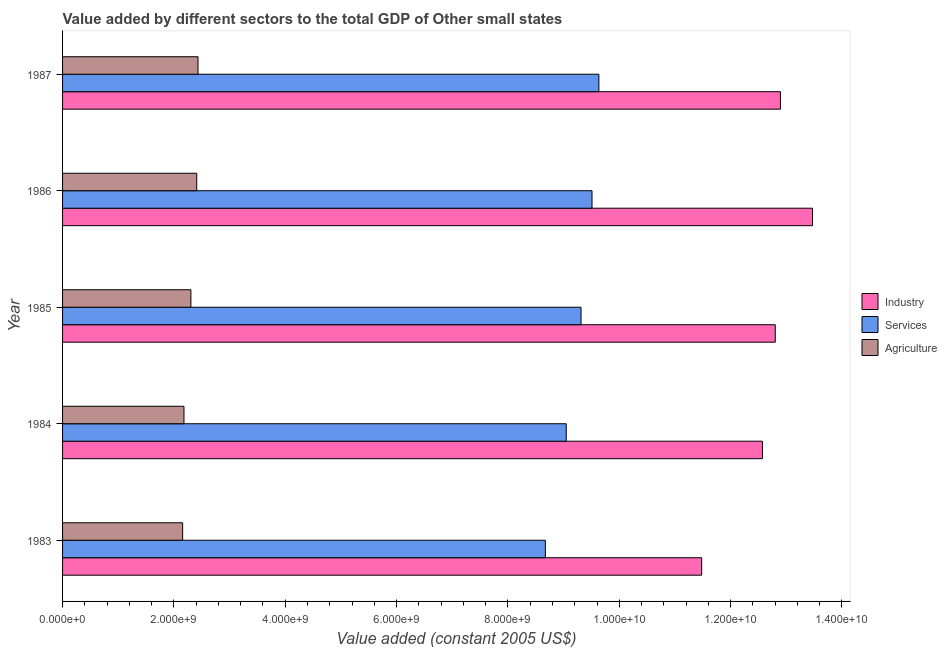How many groups of bars are there?
Give a very brief answer. 5. Are the number of bars per tick equal to the number of legend labels?
Give a very brief answer. Yes. Are the number of bars on each tick of the Y-axis equal?
Keep it short and to the point. Yes. In how many cases, is the number of bars for a given year not equal to the number of legend labels?
Your response must be concise. 0. What is the value added by agricultural sector in 1984?
Keep it short and to the point. 2.18e+09. Across all years, what is the maximum value added by agricultural sector?
Your response must be concise. 2.43e+09. Across all years, what is the minimum value added by industrial sector?
Make the answer very short. 1.15e+1. What is the total value added by industrial sector in the graph?
Your answer should be compact. 6.32e+1. What is the difference between the value added by services in 1983 and that in 1984?
Keep it short and to the point. -3.75e+08. What is the difference between the value added by industrial sector in 1985 and the value added by agricultural sector in 1983?
Provide a succinct answer. 1.06e+1. What is the average value added by services per year?
Ensure brevity in your answer.  9.23e+09. In the year 1983, what is the difference between the value added by services and value added by industrial sector?
Provide a short and direct response. -2.81e+09. In how many years, is the value added by services greater than 1600000000 US$?
Offer a very short reply. 5. What is the ratio of the value added by services in 1983 to that in 1986?
Make the answer very short. 0.91. Is the value added by industrial sector in 1986 less than that in 1987?
Your answer should be compact. No. Is the difference between the value added by industrial sector in 1985 and 1986 greater than the difference between the value added by services in 1985 and 1986?
Provide a short and direct response. No. What is the difference between the highest and the second highest value added by industrial sector?
Offer a terse response. 5.76e+08. What is the difference between the highest and the lowest value added by agricultural sector?
Provide a short and direct response. 2.76e+08. In how many years, is the value added by agricultural sector greater than the average value added by agricultural sector taken over all years?
Provide a short and direct response. 3. What does the 2nd bar from the top in 1987 represents?
Your answer should be compact. Services. What does the 1st bar from the bottom in 1987 represents?
Give a very brief answer. Industry. How many bars are there?
Offer a very short reply. 15. How many years are there in the graph?
Your answer should be compact. 5. Are the values on the major ticks of X-axis written in scientific E-notation?
Your answer should be compact. Yes. Does the graph contain any zero values?
Your answer should be compact. No. Does the graph contain grids?
Your answer should be compact. No. Where does the legend appear in the graph?
Provide a short and direct response. Center right. How many legend labels are there?
Make the answer very short. 3. How are the legend labels stacked?
Offer a terse response. Vertical. What is the title of the graph?
Ensure brevity in your answer.  Value added by different sectors to the total GDP of Other small states. What is the label or title of the X-axis?
Your response must be concise. Value added (constant 2005 US$). What is the label or title of the Y-axis?
Make the answer very short. Year. What is the Value added (constant 2005 US$) in Industry in 1983?
Keep it short and to the point. 1.15e+1. What is the Value added (constant 2005 US$) of Services in 1983?
Offer a terse response. 8.67e+09. What is the Value added (constant 2005 US$) of Agriculture in 1983?
Offer a very short reply. 2.16e+09. What is the Value added (constant 2005 US$) in Industry in 1984?
Your response must be concise. 1.26e+1. What is the Value added (constant 2005 US$) in Services in 1984?
Provide a succinct answer. 9.05e+09. What is the Value added (constant 2005 US$) in Agriculture in 1984?
Ensure brevity in your answer.  2.18e+09. What is the Value added (constant 2005 US$) in Industry in 1985?
Give a very brief answer. 1.28e+1. What is the Value added (constant 2005 US$) in Services in 1985?
Offer a very short reply. 9.31e+09. What is the Value added (constant 2005 US$) in Agriculture in 1985?
Offer a terse response. 2.30e+09. What is the Value added (constant 2005 US$) in Industry in 1986?
Make the answer very short. 1.35e+1. What is the Value added (constant 2005 US$) in Services in 1986?
Your answer should be compact. 9.51e+09. What is the Value added (constant 2005 US$) of Agriculture in 1986?
Your answer should be very brief. 2.41e+09. What is the Value added (constant 2005 US$) of Industry in 1987?
Provide a succinct answer. 1.29e+1. What is the Value added (constant 2005 US$) in Services in 1987?
Your response must be concise. 9.63e+09. What is the Value added (constant 2005 US$) in Agriculture in 1987?
Ensure brevity in your answer.  2.43e+09. Across all years, what is the maximum Value added (constant 2005 US$) of Industry?
Keep it short and to the point. 1.35e+1. Across all years, what is the maximum Value added (constant 2005 US$) in Services?
Provide a succinct answer. 9.63e+09. Across all years, what is the maximum Value added (constant 2005 US$) of Agriculture?
Offer a terse response. 2.43e+09. Across all years, what is the minimum Value added (constant 2005 US$) in Industry?
Offer a very short reply. 1.15e+1. Across all years, what is the minimum Value added (constant 2005 US$) in Services?
Provide a succinct answer. 8.67e+09. Across all years, what is the minimum Value added (constant 2005 US$) in Agriculture?
Your response must be concise. 2.16e+09. What is the total Value added (constant 2005 US$) in Industry in the graph?
Your answer should be very brief. 6.32e+1. What is the total Value added (constant 2005 US$) of Services in the graph?
Offer a very short reply. 4.62e+1. What is the total Value added (constant 2005 US$) in Agriculture in the graph?
Make the answer very short. 1.15e+1. What is the difference between the Value added (constant 2005 US$) of Industry in 1983 and that in 1984?
Provide a succinct answer. -1.09e+09. What is the difference between the Value added (constant 2005 US$) in Services in 1983 and that in 1984?
Provide a short and direct response. -3.75e+08. What is the difference between the Value added (constant 2005 US$) of Agriculture in 1983 and that in 1984?
Give a very brief answer. -2.37e+07. What is the difference between the Value added (constant 2005 US$) of Industry in 1983 and that in 1985?
Provide a short and direct response. -1.32e+09. What is the difference between the Value added (constant 2005 US$) of Services in 1983 and that in 1985?
Your answer should be very brief. -6.41e+08. What is the difference between the Value added (constant 2005 US$) in Agriculture in 1983 and that in 1985?
Provide a short and direct response. -1.48e+08. What is the difference between the Value added (constant 2005 US$) of Industry in 1983 and that in 1986?
Offer a very short reply. -1.99e+09. What is the difference between the Value added (constant 2005 US$) in Services in 1983 and that in 1986?
Your answer should be compact. -8.38e+08. What is the difference between the Value added (constant 2005 US$) of Agriculture in 1983 and that in 1986?
Provide a short and direct response. -2.53e+08. What is the difference between the Value added (constant 2005 US$) in Industry in 1983 and that in 1987?
Your answer should be very brief. -1.42e+09. What is the difference between the Value added (constant 2005 US$) of Services in 1983 and that in 1987?
Ensure brevity in your answer.  -9.61e+08. What is the difference between the Value added (constant 2005 US$) of Agriculture in 1983 and that in 1987?
Ensure brevity in your answer.  -2.76e+08. What is the difference between the Value added (constant 2005 US$) of Industry in 1984 and that in 1985?
Make the answer very short. -2.31e+08. What is the difference between the Value added (constant 2005 US$) of Services in 1984 and that in 1985?
Make the answer very short. -2.66e+08. What is the difference between the Value added (constant 2005 US$) of Agriculture in 1984 and that in 1985?
Your response must be concise. -1.24e+08. What is the difference between the Value added (constant 2005 US$) in Industry in 1984 and that in 1986?
Keep it short and to the point. -8.99e+08. What is the difference between the Value added (constant 2005 US$) of Services in 1984 and that in 1986?
Ensure brevity in your answer.  -4.63e+08. What is the difference between the Value added (constant 2005 US$) in Agriculture in 1984 and that in 1986?
Provide a succinct answer. -2.29e+08. What is the difference between the Value added (constant 2005 US$) in Industry in 1984 and that in 1987?
Keep it short and to the point. -3.24e+08. What is the difference between the Value added (constant 2005 US$) in Services in 1984 and that in 1987?
Offer a terse response. -5.86e+08. What is the difference between the Value added (constant 2005 US$) in Agriculture in 1984 and that in 1987?
Your response must be concise. -2.52e+08. What is the difference between the Value added (constant 2005 US$) in Industry in 1985 and that in 1986?
Give a very brief answer. -6.69e+08. What is the difference between the Value added (constant 2005 US$) in Services in 1985 and that in 1986?
Your answer should be very brief. -1.97e+08. What is the difference between the Value added (constant 2005 US$) in Agriculture in 1985 and that in 1986?
Ensure brevity in your answer.  -1.05e+08. What is the difference between the Value added (constant 2005 US$) of Industry in 1985 and that in 1987?
Your answer should be compact. -9.30e+07. What is the difference between the Value added (constant 2005 US$) in Services in 1985 and that in 1987?
Provide a short and direct response. -3.20e+08. What is the difference between the Value added (constant 2005 US$) of Agriculture in 1985 and that in 1987?
Make the answer very short. -1.28e+08. What is the difference between the Value added (constant 2005 US$) in Industry in 1986 and that in 1987?
Offer a terse response. 5.76e+08. What is the difference between the Value added (constant 2005 US$) in Services in 1986 and that in 1987?
Keep it short and to the point. -1.23e+08. What is the difference between the Value added (constant 2005 US$) of Agriculture in 1986 and that in 1987?
Provide a succinct answer. -2.30e+07. What is the difference between the Value added (constant 2005 US$) in Industry in 1983 and the Value added (constant 2005 US$) in Services in 1984?
Provide a succinct answer. 2.43e+09. What is the difference between the Value added (constant 2005 US$) in Industry in 1983 and the Value added (constant 2005 US$) in Agriculture in 1984?
Give a very brief answer. 9.30e+09. What is the difference between the Value added (constant 2005 US$) of Services in 1983 and the Value added (constant 2005 US$) of Agriculture in 1984?
Make the answer very short. 6.49e+09. What is the difference between the Value added (constant 2005 US$) in Industry in 1983 and the Value added (constant 2005 US$) in Services in 1985?
Ensure brevity in your answer.  2.17e+09. What is the difference between the Value added (constant 2005 US$) in Industry in 1983 and the Value added (constant 2005 US$) in Agriculture in 1985?
Provide a succinct answer. 9.17e+09. What is the difference between the Value added (constant 2005 US$) of Services in 1983 and the Value added (constant 2005 US$) of Agriculture in 1985?
Make the answer very short. 6.37e+09. What is the difference between the Value added (constant 2005 US$) of Industry in 1983 and the Value added (constant 2005 US$) of Services in 1986?
Your answer should be very brief. 1.97e+09. What is the difference between the Value added (constant 2005 US$) of Industry in 1983 and the Value added (constant 2005 US$) of Agriculture in 1986?
Provide a short and direct response. 9.07e+09. What is the difference between the Value added (constant 2005 US$) in Services in 1983 and the Value added (constant 2005 US$) in Agriculture in 1986?
Offer a very short reply. 6.26e+09. What is the difference between the Value added (constant 2005 US$) of Industry in 1983 and the Value added (constant 2005 US$) of Services in 1987?
Provide a short and direct response. 1.85e+09. What is the difference between the Value added (constant 2005 US$) of Industry in 1983 and the Value added (constant 2005 US$) of Agriculture in 1987?
Ensure brevity in your answer.  9.05e+09. What is the difference between the Value added (constant 2005 US$) of Services in 1983 and the Value added (constant 2005 US$) of Agriculture in 1987?
Ensure brevity in your answer.  6.24e+09. What is the difference between the Value added (constant 2005 US$) in Industry in 1984 and the Value added (constant 2005 US$) in Services in 1985?
Offer a terse response. 3.26e+09. What is the difference between the Value added (constant 2005 US$) of Industry in 1984 and the Value added (constant 2005 US$) of Agriculture in 1985?
Ensure brevity in your answer.  1.03e+1. What is the difference between the Value added (constant 2005 US$) in Services in 1984 and the Value added (constant 2005 US$) in Agriculture in 1985?
Keep it short and to the point. 6.74e+09. What is the difference between the Value added (constant 2005 US$) of Industry in 1984 and the Value added (constant 2005 US$) of Services in 1986?
Provide a succinct answer. 3.06e+09. What is the difference between the Value added (constant 2005 US$) in Industry in 1984 and the Value added (constant 2005 US$) in Agriculture in 1986?
Offer a very short reply. 1.02e+1. What is the difference between the Value added (constant 2005 US$) of Services in 1984 and the Value added (constant 2005 US$) of Agriculture in 1986?
Provide a short and direct response. 6.64e+09. What is the difference between the Value added (constant 2005 US$) in Industry in 1984 and the Value added (constant 2005 US$) in Services in 1987?
Your answer should be compact. 2.94e+09. What is the difference between the Value added (constant 2005 US$) in Industry in 1984 and the Value added (constant 2005 US$) in Agriculture in 1987?
Your answer should be compact. 1.01e+1. What is the difference between the Value added (constant 2005 US$) in Services in 1984 and the Value added (constant 2005 US$) in Agriculture in 1987?
Your answer should be compact. 6.61e+09. What is the difference between the Value added (constant 2005 US$) of Industry in 1985 and the Value added (constant 2005 US$) of Services in 1986?
Keep it short and to the point. 3.29e+09. What is the difference between the Value added (constant 2005 US$) of Industry in 1985 and the Value added (constant 2005 US$) of Agriculture in 1986?
Ensure brevity in your answer.  1.04e+1. What is the difference between the Value added (constant 2005 US$) in Services in 1985 and the Value added (constant 2005 US$) in Agriculture in 1986?
Keep it short and to the point. 6.90e+09. What is the difference between the Value added (constant 2005 US$) in Industry in 1985 and the Value added (constant 2005 US$) in Services in 1987?
Keep it short and to the point. 3.17e+09. What is the difference between the Value added (constant 2005 US$) in Industry in 1985 and the Value added (constant 2005 US$) in Agriculture in 1987?
Give a very brief answer. 1.04e+1. What is the difference between the Value added (constant 2005 US$) of Services in 1985 and the Value added (constant 2005 US$) of Agriculture in 1987?
Ensure brevity in your answer.  6.88e+09. What is the difference between the Value added (constant 2005 US$) of Industry in 1986 and the Value added (constant 2005 US$) of Services in 1987?
Give a very brief answer. 3.84e+09. What is the difference between the Value added (constant 2005 US$) of Industry in 1986 and the Value added (constant 2005 US$) of Agriculture in 1987?
Offer a very short reply. 1.10e+1. What is the difference between the Value added (constant 2005 US$) in Services in 1986 and the Value added (constant 2005 US$) in Agriculture in 1987?
Offer a very short reply. 7.08e+09. What is the average Value added (constant 2005 US$) in Industry per year?
Your response must be concise. 1.26e+1. What is the average Value added (constant 2005 US$) of Services per year?
Ensure brevity in your answer.  9.23e+09. What is the average Value added (constant 2005 US$) in Agriculture per year?
Make the answer very short. 2.30e+09. In the year 1983, what is the difference between the Value added (constant 2005 US$) in Industry and Value added (constant 2005 US$) in Services?
Make the answer very short. 2.81e+09. In the year 1983, what is the difference between the Value added (constant 2005 US$) of Industry and Value added (constant 2005 US$) of Agriculture?
Offer a terse response. 9.32e+09. In the year 1983, what is the difference between the Value added (constant 2005 US$) in Services and Value added (constant 2005 US$) in Agriculture?
Give a very brief answer. 6.51e+09. In the year 1984, what is the difference between the Value added (constant 2005 US$) in Industry and Value added (constant 2005 US$) in Services?
Give a very brief answer. 3.52e+09. In the year 1984, what is the difference between the Value added (constant 2005 US$) in Industry and Value added (constant 2005 US$) in Agriculture?
Offer a terse response. 1.04e+1. In the year 1984, what is the difference between the Value added (constant 2005 US$) of Services and Value added (constant 2005 US$) of Agriculture?
Keep it short and to the point. 6.87e+09. In the year 1985, what is the difference between the Value added (constant 2005 US$) of Industry and Value added (constant 2005 US$) of Services?
Ensure brevity in your answer.  3.49e+09. In the year 1985, what is the difference between the Value added (constant 2005 US$) of Industry and Value added (constant 2005 US$) of Agriculture?
Provide a short and direct response. 1.05e+1. In the year 1985, what is the difference between the Value added (constant 2005 US$) of Services and Value added (constant 2005 US$) of Agriculture?
Make the answer very short. 7.01e+09. In the year 1986, what is the difference between the Value added (constant 2005 US$) of Industry and Value added (constant 2005 US$) of Services?
Ensure brevity in your answer.  3.96e+09. In the year 1986, what is the difference between the Value added (constant 2005 US$) of Industry and Value added (constant 2005 US$) of Agriculture?
Give a very brief answer. 1.11e+1. In the year 1986, what is the difference between the Value added (constant 2005 US$) of Services and Value added (constant 2005 US$) of Agriculture?
Offer a very short reply. 7.10e+09. In the year 1987, what is the difference between the Value added (constant 2005 US$) of Industry and Value added (constant 2005 US$) of Services?
Provide a short and direct response. 3.26e+09. In the year 1987, what is the difference between the Value added (constant 2005 US$) in Industry and Value added (constant 2005 US$) in Agriculture?
Offer a very short reply. 1.05e+1. In the year 1987, what is the difference between the Value added (constant 2005 US$) in Services and Value added (constant 2005 US$) in Agriculture?
Keep it short and to the point. 7.20e+09. What is the ratio of the Value added (constant 2005 US$) in Industry in 1983 to that in 1984?
Provide a short and direct response. 0.91. What is the ratio of the Value added (constant 2005 US$) of Services in 1983 to that in 1984?
Offer a terse response. 0.96. What is the ratio of the Value added (constant 2005 US$) of Agriculture in 1983 to that in 1984?
Give a very brief answer. 0.99. What is the ratio of the Value added (constant 2005 US$) of Industry in 1983 to that in 1985?
Offer a very short reply. 0.9. What is the ratio of the Value added (constant 2005 US$) in Services in 1983 to that in 1985?
Your answer should be compact. 0.93. What is the ratio of the Value added (constant 2005 US$) in Agriculture in 1983 to that in 1985?
Make the answer very short. 0.94. What is the ratio of the Value added (constant 2005 US$) in Industry in 1983 to that in 1986?
Your answer should be very brief. 0.85. What is the ratio of the Value added (constant 2005 US$) in Services in 1983 to that in 1986?
Ensure brevity in your answer.  0.91. What is the ratio of the Value added (constant 2005 US$) of Agriculture in 1983 to that in 1986?
Provide a succinct answer. 0.9. What is the ratio of the Value added (constant 2005 US$) of Industry in 1983 to that in 1987?
Make the answer very short. 0.89. What is the ratio of the Value added (constant 2005 US$) of Services in 1983 to that in 1987?
Offer a very short reply. 0.9. What is the ratio of the Value added (constant 2005 US$) of Agriculture in 1983 to that in 1987?
Offer a terse response. 0.89. What is the ratio of the Value added (constant 2005 US$) of Services in 1984 to that in 1985?
Ensure brevity in your answer.  0.97. What is the ratio of the Value added (constant 2005 US$) of Agriculture in 1984 to that in 1985?
Your response must be concise. 0.95. What is the ratio of the Value added (constant 2005 US$) of Industry in 1984 to that in 1986?
Make the answer very short. 0.93. What is the ratio of the Value added (constant 2005 US$) of Services in 1984 to that in 1986?
Provide a short and direct response. 0.95. What is the ratio of the Value added (constant 2005 US$) of Agriculture in 1984 to that in 1986?
Provide a short and direct response. 0.9. What is the ratio of the Value added (constant 2005 US$) in Industry in 1984 to that in 1987?
Your answer should be very brief. 0.97. What is the ratio of the Value added (constant 2005 US$) of Services in 1984 to that in 1987?
Give a very brief answer. 0.94. What is the ratio of the Value added (constant 2005 US$) of Agriculture in 1984 to that in 1987?
Give a very brief answer. 0.9. What is the ratio of the Value added (constant 2005 US$) in Industry in 1985 to that in 1986?
Your answer should be very brief. 0.95. What is the ratio of the Value added (constant 2005 US$) in Services in 1985 to that in 1986?
Offer a very short reply. 0.98. What is the ratio of the Value added (constant 2005 US$) in Agriculture in 1985 to that in 1986?
Provide a short and direct response. 0.96. What is the ratio of the Value added (constant 2005 US$) of Industry in 1985 to that in 1987?
Offer a very short reply. 0.99. What is the ratio of the Value added (constant 2005 US$) in Services in 1985 to that in 1987?
Offer a very short reply. 0.97. What is the ratio of the Value added (constant 2005 US$) in Agriculture in 1985 to that in 1987?
Provide a succinct answer. 0.95. What is the ratio of the Value added (constant 2005 US$) in Industry in 1986 to that in 1987?
Provide a succinct answer. 1.04. What is the ratio of the Value added (constant 2005 US$) of Services in 1986 to that in 1987?
Your answer should be compact. 0.99. What is the ratio of the Value added (constant 2005 US$) in Agriculture in 1986 to that in 1987?
Offer a very short reply. 0.99. What is the difference between the highest and the second highest Value added (constant 2005 US$) in Industry?
Make the answer very short. 5.76e+08. What is the difference between the highest and the second highest Value added (constant 2005 US$) of Services?
Keep it short and to the point. 1.23e+08. What is the difference between the highest and the second highest Value added (constant 2005 US$) in Agriculture?
Give a very brief answer. 2.30e+07. What is the difference between the highest and the lowest Value added (constant 2005 US$) in Industry?
Ensure brevity in your answer.  1.99e+09. What is the difference between the highest and the lowest Value added (constant 2005 US$) of Services?
Ensure brevity in your answer.  9.61e+08. What is the difference between the highest and the lowest Value added (constant 2005 US$) of Agriculture?
Offer a very short reply. 2.76e+08. 